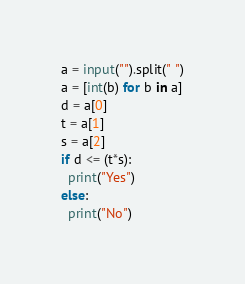Convert code to text. <code><loc_0><loc_0><loc_500><loc_500><_Python_>a = input("").split(" ")
a = [int(b) for b in a]
d = a[0]
t = a[1]
s = a[2]
if d <= (t*s):
  print("Yes")
else:
  print("No")</code> 